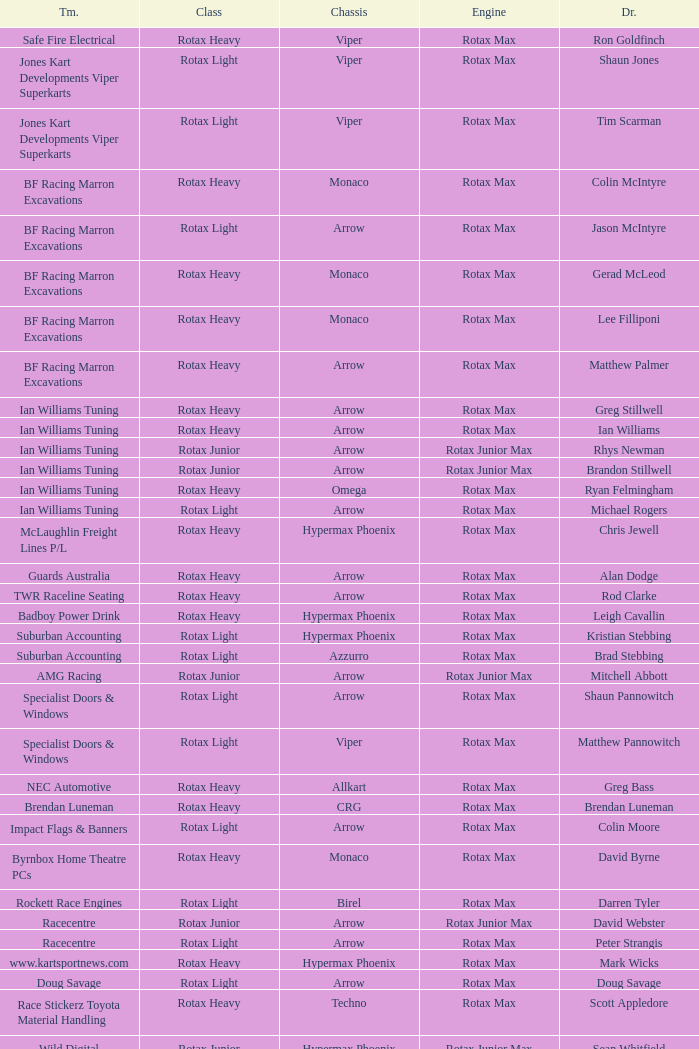What type of engine does the BF Racing Marron Excavations have that also has Monaco as chassis and Lee Filliponi as the driver? Rotax Max. 